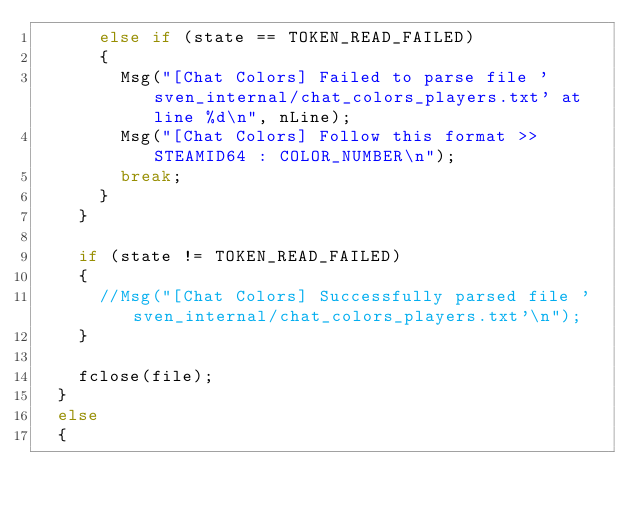Convert code to text. <code><loc_0><loc_0><loc_500><loc_500><_C++_>			else if (state == TOKEN_READ_FAILED)
			{
				Msg("[Chat Colors] Failed to parse file 'sven_internal/chat_colors_players.txt' at line %d\n", nLine);
				Msg("[Chat Colors] Follow this format >> STEAMID64 : COLOR_NUMBER\n");
				break;
			}
		}

		if (state != TOKEN_READ_FAILED)
		{
			//Msg("[Chat Colors] Successfully parsed file 'sven_internal/chat_colors_players.txt'\n");
		}

		fclose(file);
	}
	else
	{</code> 